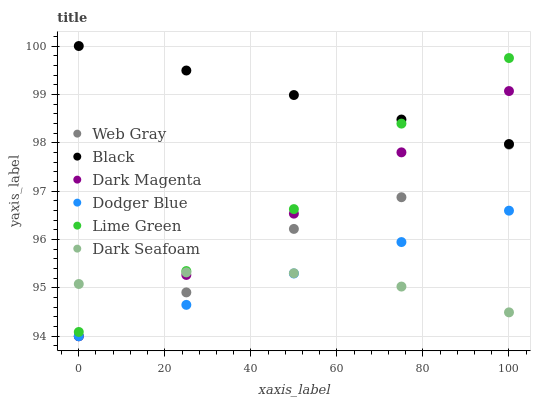Does Dark Seafoam have the minimum area under the curve?
Answer yes or no. Yes. Does Black have the maximum area under the curve?
Answer yes or no. Yes. Does Dark Magenta have the minimum area under the curve?
Answer yes or no. No. Does Dark Magenta have the maximum area under the curve?
Answer yes or no. No. Is Dark Magenta the smoothest?
Answer yes or no. Yes. Is Web Gray the roughest?
Answer yes or no. Yes. Is Dark Seafoam the smoothest?
Answer yes or no. No. Is Dark Seafoam the roughest?
Answer yes or no. No. Does Web Gray have the lowest value?
Answer yes or no. Yes. Does Dark Seafoam have the lowest value?
Answer yes or no. No. Does Black have the highest value?
Answer yes or no. Yes. Does Dark Magenta have the highest value?
Answer yes or no. No. Is Web Gray less than Black?
Answer yes or no. Yes. Is Lime Green greater than Web Gray?
Answer yes or no. Yes. Does Dark Magenta intersect Dark Seafoam?
Answer yes or no. Yes. Is Dark Magenta less than Dark Seafoam?
Answer yes or no. No. Is Dark Magenta greater than Dark Seafoam?
Answer yes or no. No. Does Web Gray intersect Black?
Answer yes or no. No. 